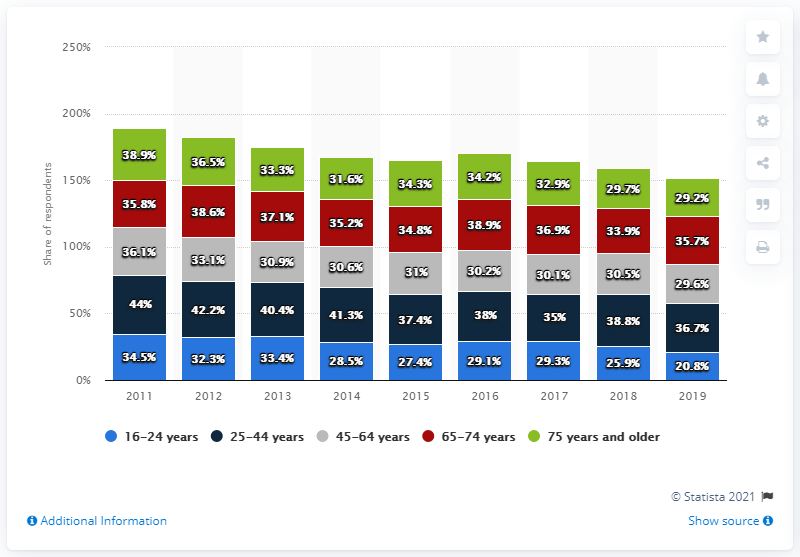Highlight a few significant elements in this photo. In 2019, approximately 20.8% of individuals aged 16-24 reported visiting a public library. 